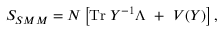Convert formula to latex. <formula><loc_0><loc_0><loc_500><loc_500>S _ { S M M } = N \left [ T r \, Y ^ { - 1 } \Lambda + V ( Y ) \right ] ,</formula> 